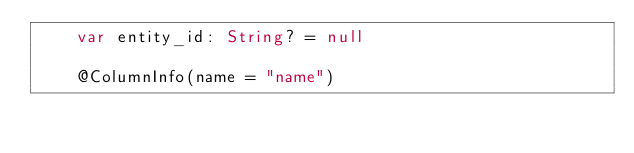Convert code to text. <code><loc_0><loc_0><loc_500><loc_500><_Kotlin_>    var entity_id: String? = null

    @ColumnInfo(name = "name")</code> 